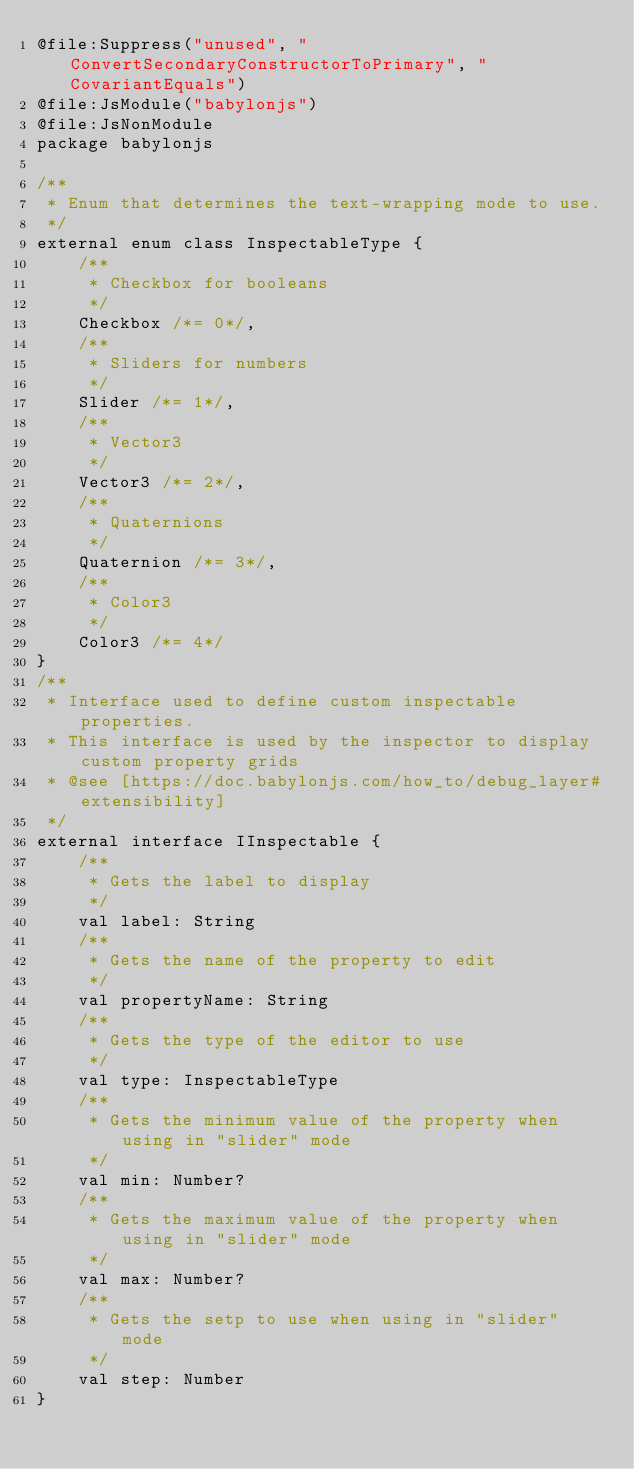Convert code to text. <code><loc_0><loc_0><loc_500><loc_500><_Kotlin_>@file:Suppress("unused", "ConvertSecondaryConstructorToPrimary", "CovariantEquals")
@file:JsModule("babylonjs")
@file:JsNonModule
package babylonjs

/**
 * Enum that determines the text-wrapping mode to use.
 */
external enum class InspectableType {
    /**
     * Checkbox for booleans
     */
    Checkbox /*= 0*/,
    /**
     * Sliders for numbers
     */
    Slider /*= 1*/,
    /**
     * Vector3
     */
    Vector3 /*= 2*/,
    /**
     * Quaternions
     */
    Quaternion /*= 3*/,
    /**
     * Color3
     */
    Color3 /*= 4*/
}
/**
 * Interface used to define custom inspectable properties.
 * This interface is used by the inspector to display custom property grids
 * @see [https://doc.babylonjs.com/how_to/debug_layer#extensibility]
 */
external interface IInspectable {
    /**
     * Gets the label to display
     */
    val label: String
    /**
     * Gets the name of the property to edit
     */
    val propertyName: String
    /**
     * Gets the type of the editor to use
     */
    val type: InspectableType
    /**
     * Gets the minimum value of the property when using in "slider" mode
     */
    val min: Number?
    /**
     * Gets the maximum value of the property when using in "slider" mode
     */
    val max: Number?
    /**
     * Gets the setp to use when using in "slider" mode
     */
    val step: Number
}
</code> 